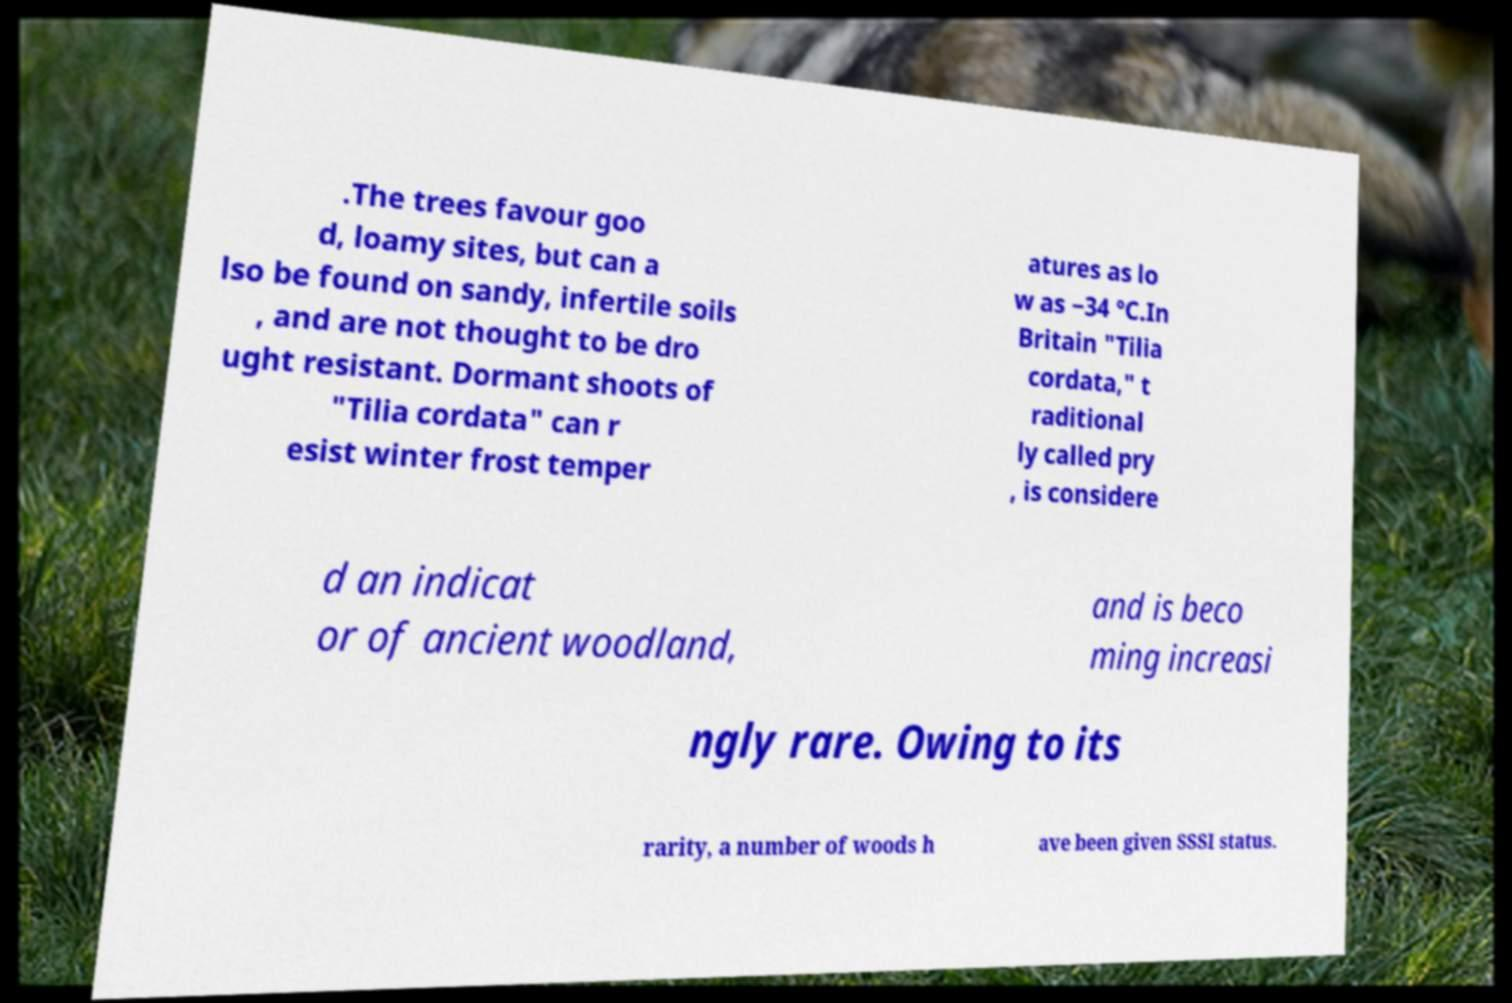Could you assist in decoding the text presented in this image and type it out clearly? .The trees favour goo d, loamy sites, but can a lso be found on sandy, infertile soils , and are not thought to be dro ught resistant. Dormant shoots of "Tilia cordata" can r esist winter frost temper atures as lo w as −34 °C.In Britain "Tilia cordata," t raditional ly called pry , is considere d an indicat or of ancient woodland, and is beco ming increasi ngly rare. Owing to its rarity, a number of woods h ave been given SSSI status. 